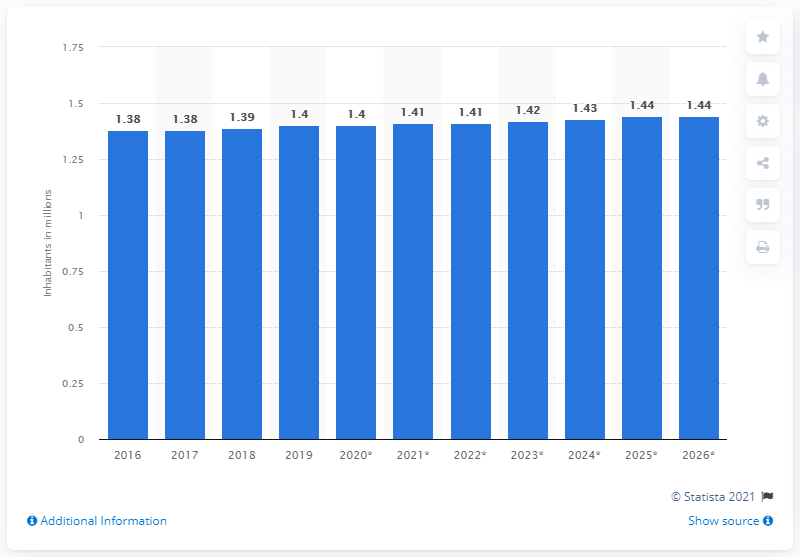Give some essential details in this illustration. As of 2019, the population of Trinidad and Tobago was approximately 1.41 million. According to an estimate in 2016, the population of Trinidad and Tobago was approximately 1.4 million people. 